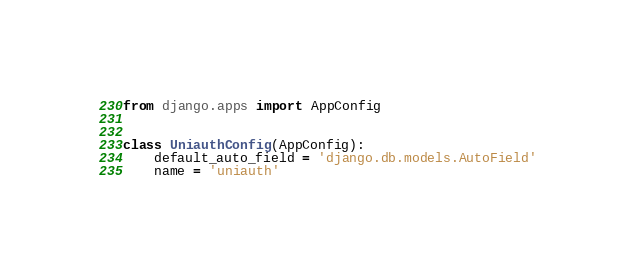<code> <loc_0><loc_0><loc_500><loc_500><_Python_>from django.apps import AppConfig


class UniauthConfig(AppConfig):
    default_auto_field = 'django.db.models.AutoField'
    name = 'uniauth'
</code> 